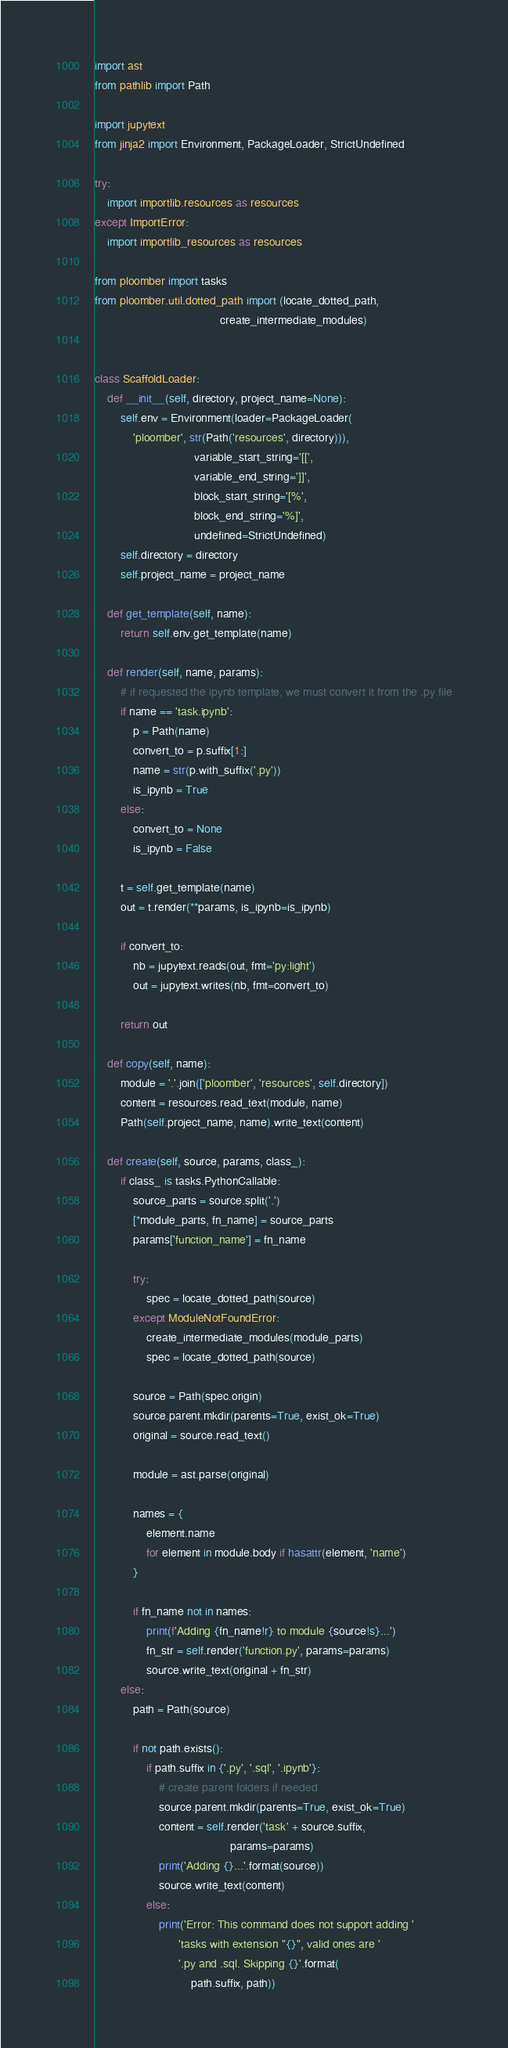<code> <loc_0><loc_0><loc_500><loc_500><_Python_>import ast
from pathlib import Path

import jupytext
from jinja2 import Environment, PackageLoader, StrictUndefined

try:
    import importlib.resources as resources
except ImportError:
    import importlib_resources as resources

from ploomber import tasks
from ploomber.util.dotted_path import (locate_dotted_path,
                                       create_intermediate_modules)


class ScaffoldLoader:
    def __init__(self, directory, project_name=None):
        self.env = Environment(loader=PackageLoader(
            'ploomber', str(Path('resources', directory))),
                               variable_start_string='[[',
                               variable_end_string=']]',
                               block_start_string='[%',
                               block_end_string='%]',
                               undefined=StrictUndefined)
        self.directory = directory
        self.project_name = project_name

    def get_template(self, name):
        return self.env.get_template(name)

    def render(self, name, params):
        # if requested the ipynb template, we must convert it from the .py file
        if name == 'task.ipynb':
            p = Path(name)
            convert_to = p.suffix[1:]
            name = str(p.with_suffix('.py'))
            is_ipynb = True
        else:
            convert_to = None
            is_ipynb = False

        t = self.get_template(name)
        out = t.render(**params, is_ipynb=is_ipynb)

        if convert_to:
            nb = jupytext.reads(out, fmt='py:light')
            out = jupytext.writes(nb, fmt=convert_to)

        return out

    def copy(self, name):
        module = '.'.join(['ploomber', 'resources', self.directory])
        content = resources.read_text(module, name)
        Path(self.project_name, name).write_text(content)

    def create(self, source, params, class_):
        if class_ is tasks.PythonCallable:
            source_parts = source.split('.')
            [*module_parts, fn_name] = source_parts
            params['function_name'] = fn_name

            try:
                spec = locate_dotted_path(source)
            except ModuleNotFoundError:
                create_intermediate_modules(module_parts)
                spec = locate_dotted_path(source)

            source = Path(spec.origin)
            source.parent.mkdir(parents=True, exist_ok=True)
            original = source.read_text()

            module = ast.parse(original)

            names = {
                element.name
                for element in module.body if hasattr(element, 'name')
            }

            if fn_name not in names:
                print(f'Adding {fn_name!r} to module {source!s}...')
                fn_str = self.render('function.py', params=params)
                source.write_text(original + fn_str)
        else:
            path = Path(source)

            if not path.exists():
                if path.suffix in {'.py', '.sql', '.ipynb'}:
                    # create parent folders if needed
                    source.parent.mkdir(parents=True, exist_ok=True)
                    content = self.render('task' + source.suffix,
                                          params=params)
                    print('Adding {}...'.format(source))
                    source.write_text(content)
                else:
                    print('Error: This command does not support adding '
                          'tasks with extension "{}", valid ones are '
                          '.py and .sql. Skipping {}'.format(
                              path.suffix, path))
</code> 